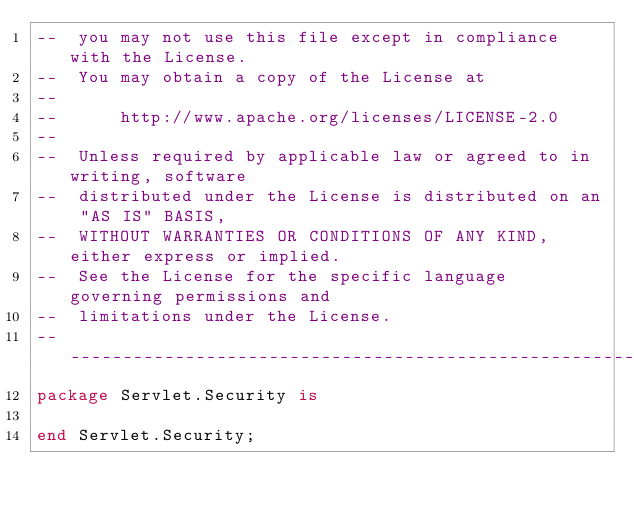Convert code to text. <code><loc_0><loc_0><loc_500><loc_500><_Ada_>--  you may not use this file except in compliance with the License.
--  You may obtain a copy of the License at
--
--      http://www.apache.org/licenses/LICENSE-2.0
--
--  Unless required by applicable law or agreed to in writing, software
--  distributed under the License is distributed on an "AS IS" BASIS,
--  WITHOUT WARRANTIES OR CONDITIONS OF ANY KIND, either express or implied.
--  See the License for the specific language governing permissions and
--  limitations under the License.
-----------------------------------------------------------------------
package Servlet.Security is

end Servlet.Security;
</code> 